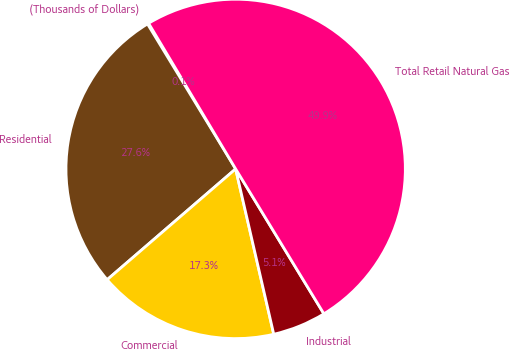Convert chart. <chart><loc_0><loc_0><loc_500><loc_500><pie_chart><fcel>(Thousands of Dollars)<fcel>Residential<fcel>Commercial<fcel>Industrial<fcel>Total Retail Natural Gas<nl><fcel>0.12%<fcel>27.63%<fcel>17.28%<fcel>5.1%<fcel>49.87%<nl></chart> 